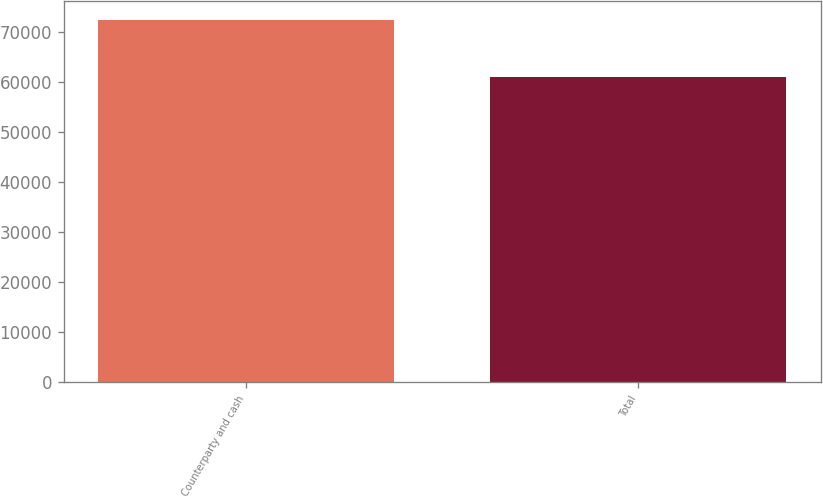<chart> <loc_0><loc_0><loc_500><loc_500><bar_chart><fcel>Counterparty and cash<fcel>Total<nl><fcel>72527<fcel>60946<nl></chart> 